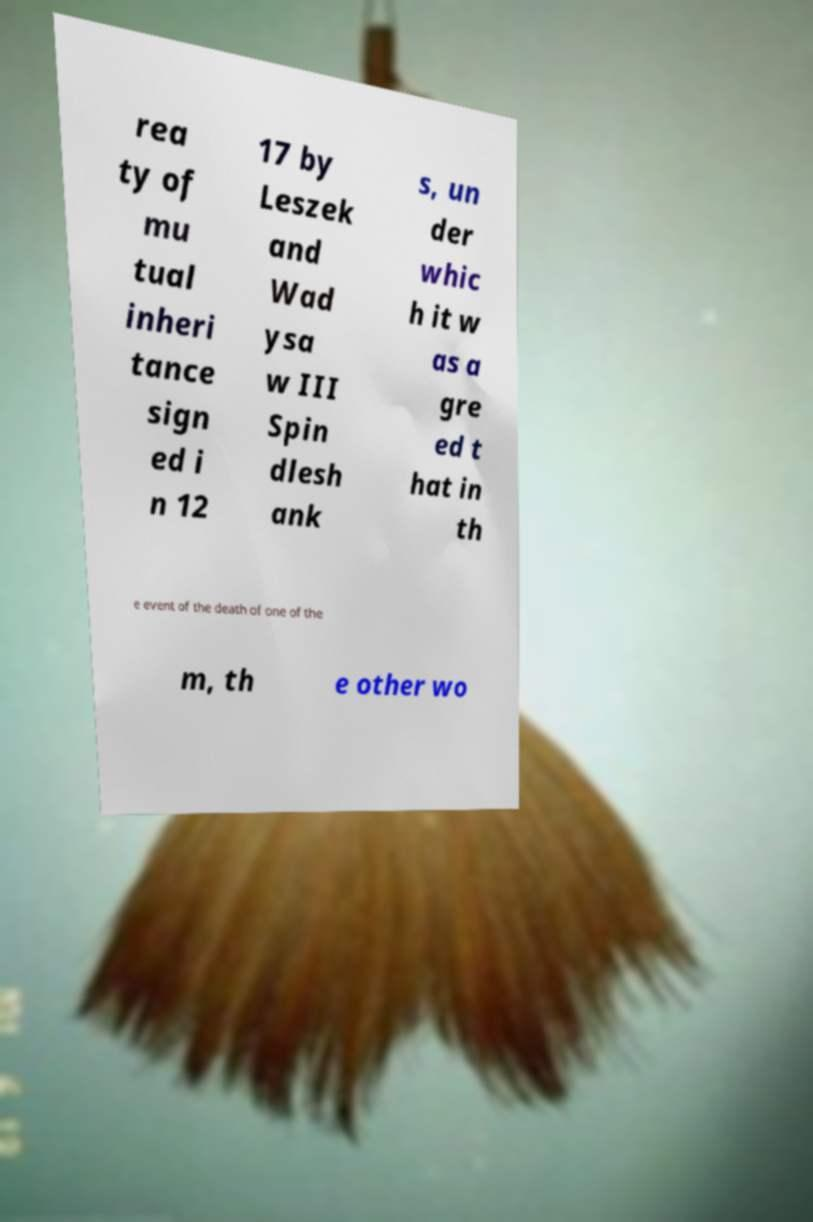Please identify and transcribe the text found in this image. rea ty of mu tual inheri tance sign ed i n 12 17 by Leszek and Wad ysa w III Spin dlesh ank s, un der whic h it w as a gre ed t hat in th e event of the death of one of the m, th e other wo 